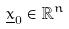Convert formula to latex. <formula><loc_0><loc_0><loc_500><loc_500>\underline { x } _ { 0 } \in \mathbb { R } ^ { n }</formula> 